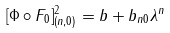<formula> <loc_0><loc_0><loc_500><loc_500>[ \Phi \circ F _ { 0 } ] ^ { 2 } _ { ( n , 0 ) } = b + b _ { n 0 } \lambda ^ { n }</formula> 